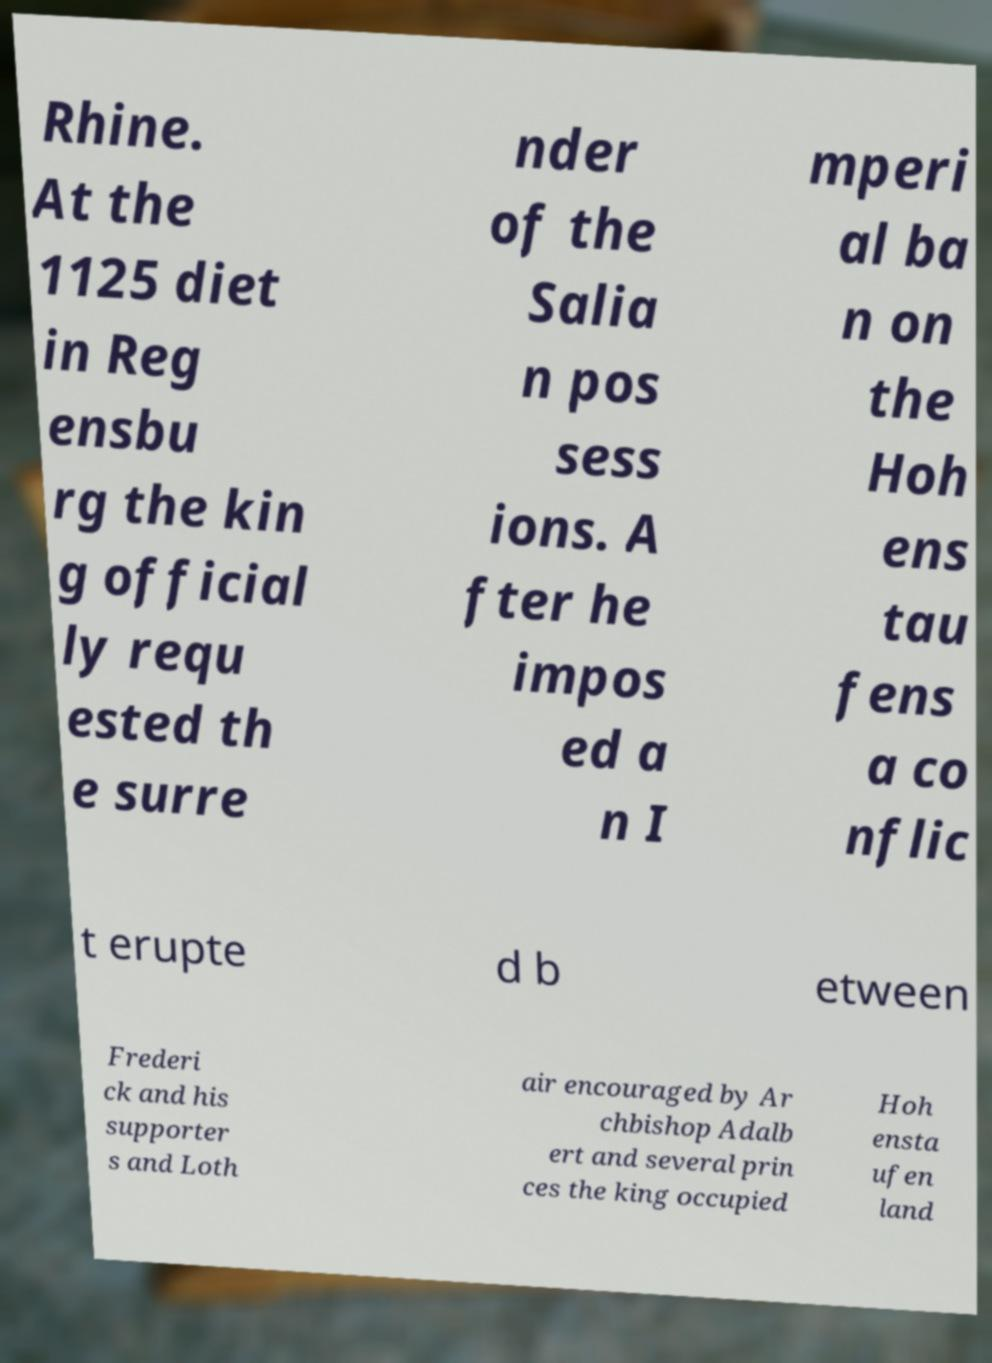Please read and relay the text visible in this image. What does it say? Rhine. At the 1125 diet in Reg ensbu rg the kin g official ly requ ested th e surre nder of the Salia n pos sess ions. A fter he impos ed a n I mperi al ba n on the Hoh ens tau fens a co nflic t erupte d b etween Frederi ck and his supporter s and Loth air encouraged by Ar chbishop Adalb ert and several prin ces the king occupied Hoh ensta ufen land 